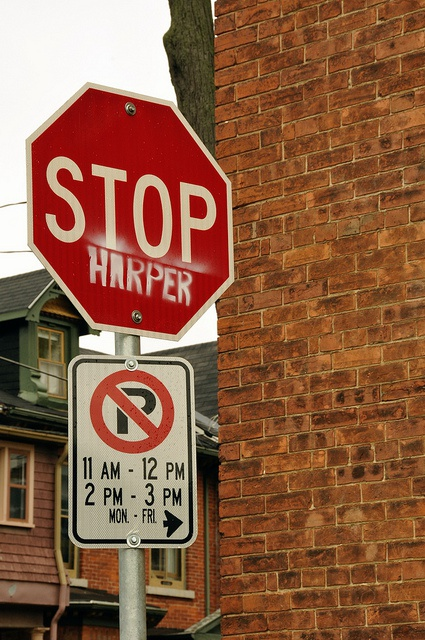Describe the objects in this image and their specific colors. I can see a stop sign in white, maroon, tan, and brown tones in this image. 